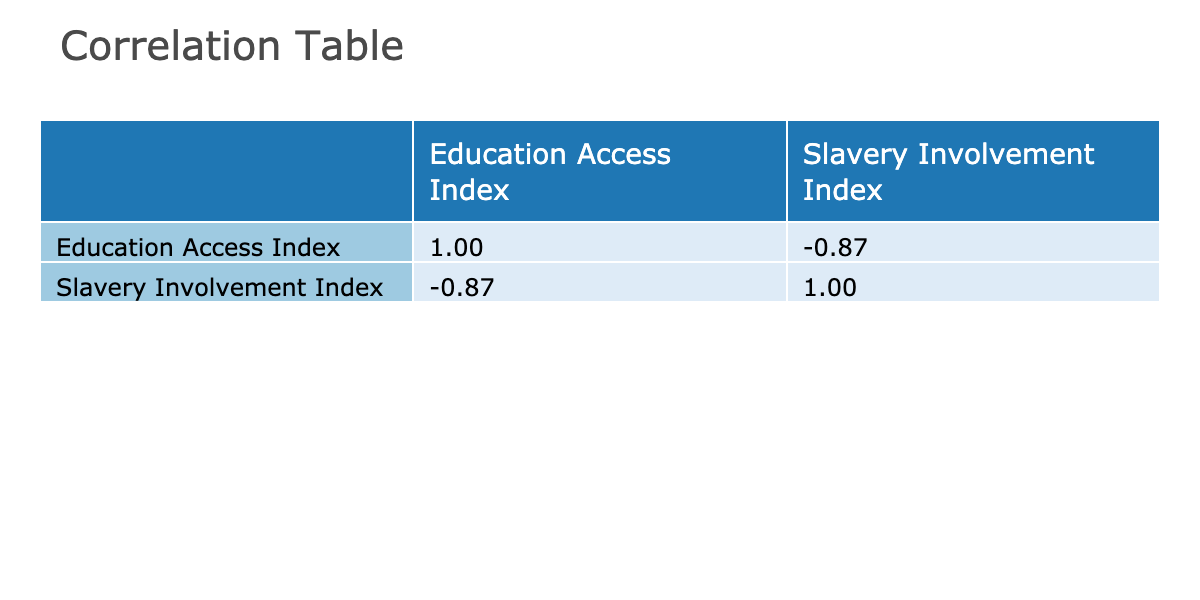What is the Education Access Index for the United Kingdom? The table lists the United Kingdom under the "Education Access Index" column, where the corresponding value is 0.92.
Answer: 0.92 Which country has the highest Slavery Involvement Index? By examining the "Slavery Involvement Index" column, Liberia has the highest value of 12.8.
Answer: Liberia Is there a positive correlation between Education Access Index and Slavery Involvement Index? The correlation coefficient between the two indices is negative, indicating an inverse relationship: education access increases as slavery involvement decreases.
Answer: No What is the difference in the Education Access Index between Nigeria and Brazil? Nigeria has an Education Access Index of 0.47, and Brazil has 0.68. The difference is calculated as 0.68 - 0.47 = 0.21.
Answer: 0.21 What is the average Slavery Involvement Index for countries with an Education Access Index below 0.5? The countries with an index below 0.5 are Nigeria (7.1), Pakistan (6.2), and Liberia (12.8). Their total is 7.1 + 6.2 + 12.8 = 26.1, and there are three countries, so the average is 26.1 / 3 = 8.7.
Answer: 8.7 Which country has the lowest Education Access Index? By scanning the "Education Access Index," it shows that Liberia has the lowest value at 0.39.
Answer: Liberia Is the United States' Slavery Involvement Index lower than that of South Africa? The United States has an index of 1.5, whereas South Africa has 4.1. Since 1.5 is less than 4.1, this is true.
Answer: Yes Calculate the total of the Education Access Index for Brazil and the United Kingdom. Brazil's index is 0.68 and the United Kingdom's is 0.92. Their total is 0.68 + 0.92 = 1.60.
Answer: 1.60 What is the ratio of Education Access Index of China to that of Nigeria? The Education Access Index for China is 0.76, while for Nigeria it is 0.47. The ratio is calculated as 0.76 / 0.47 ≈ 1.62.
Answer: 1.62 